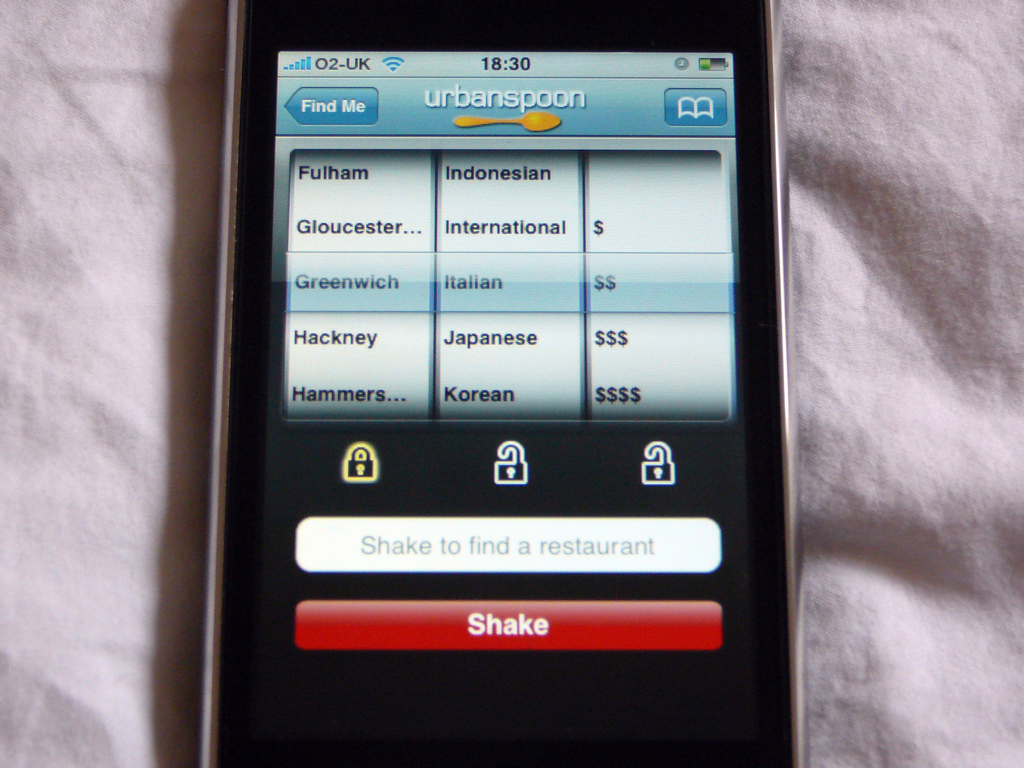Can you explain the significance of the 'Shake to find a restaurant' feature? The 'Shake to find a restaurant' feature in the Urbanspoon app adds an element of spontaneity and adventure to choosing a dining location. By shaking the device, the user is presented with a randomly selected restaurant based on their current search filters like location and cuisine. This feature caters to indecisive users or those looking for a surprise, making the dining decision process more engaging and entertaining. 